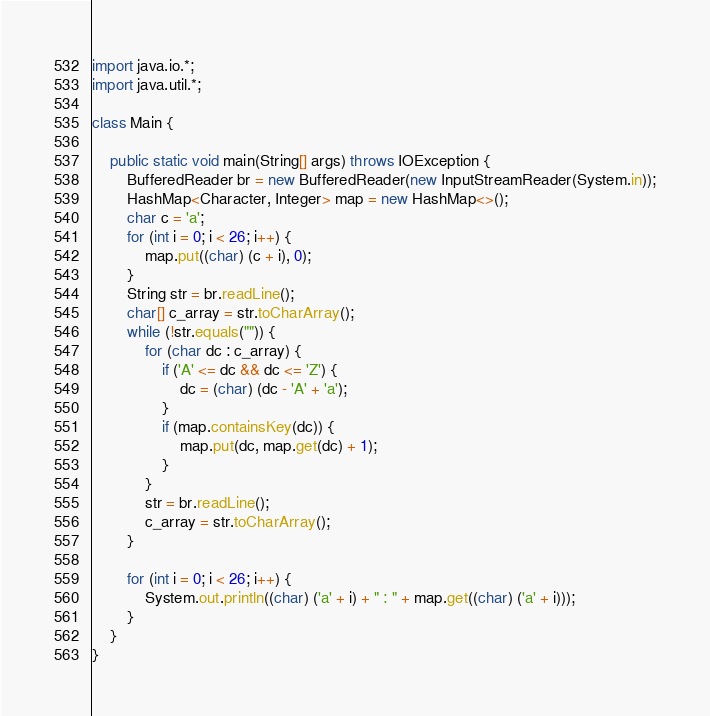<code> <loc_0><loc_0><loc_500><loc_500><_Java_>import java.io.*;
import java.util.*;

class Main {

    public static void main(String[] args) throws IOException {
        BufferedReader br = new BufferedReader(new InputStreamReader(System.in));
        HashMap<Character, Integer> map = new HashMap<>();
        char c = 'a';
        for (int i = 0; i < 26; i++) {
            map.put((char) (c + i), 0);
        }
        String str = br.readLine();
        char[] c_array = str.toCharArray();
        while (!str.equals("")) {
            for (char dc : c_array) {
                if ('A' <= dc && dc <= 'Z') {
                    dc = (char) (dc - 'A' + 'a');
                }
                if (map.containsKey(dc)) {
                    map.put(dc, map.get(dc) + 1);
                }
            }
            str = br.readLine();
            c_array = str.toCharArray();
        }

        for (int i = 0; i < 26; i++) {
            System.out.println((char) ('a' + i) + " : " + map.get((char) ('a' + i)));
        }
    }
}</code> 